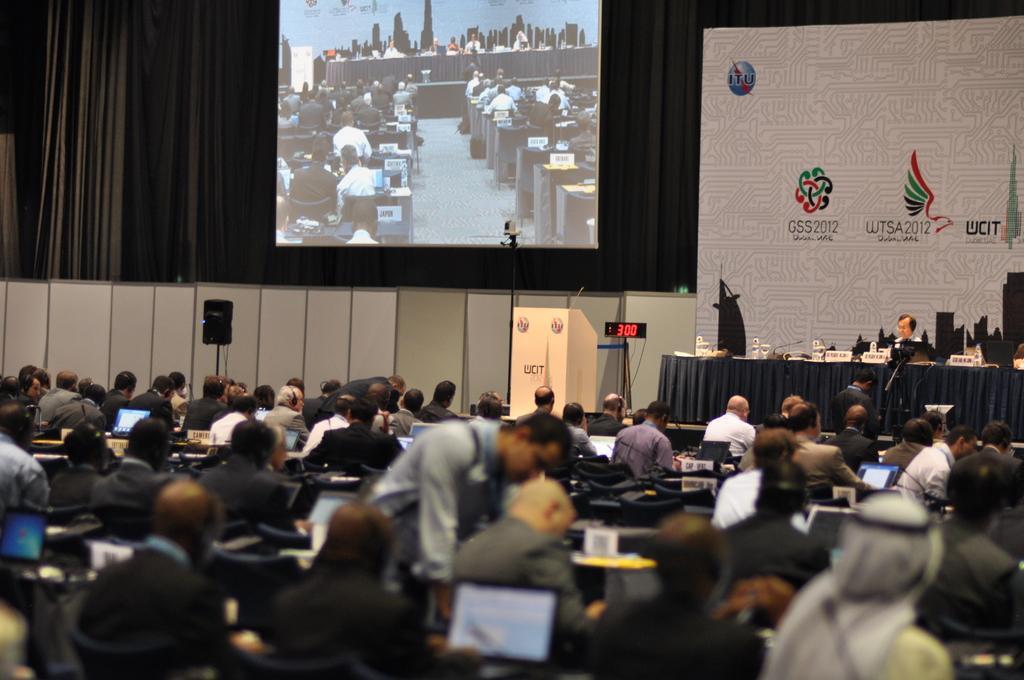Describe this image in one or two sentences. In the foreground of the image we can see a group of people are sitting on the chairs. In the middle of the image we can see a speaker, a digital display, a table and a person is sitting on the chair. On the top of the image we can see a projector display, banner and curtains. 